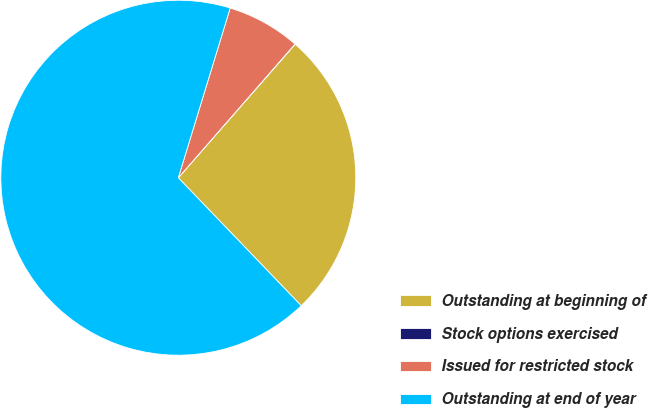Convert chart. <chart><loc_0><loc_0><loc_500><loc_500><pie_chart><fcel>Outstanding at beginning of<fcel>Stock options exercised<fcel>Issued for restricted stock<fcel>Outstanding at end of year<nl><fcel>26.38%<fcel>0.02%<fcel>6.7%<fcel>66.9%<nl></chart> 